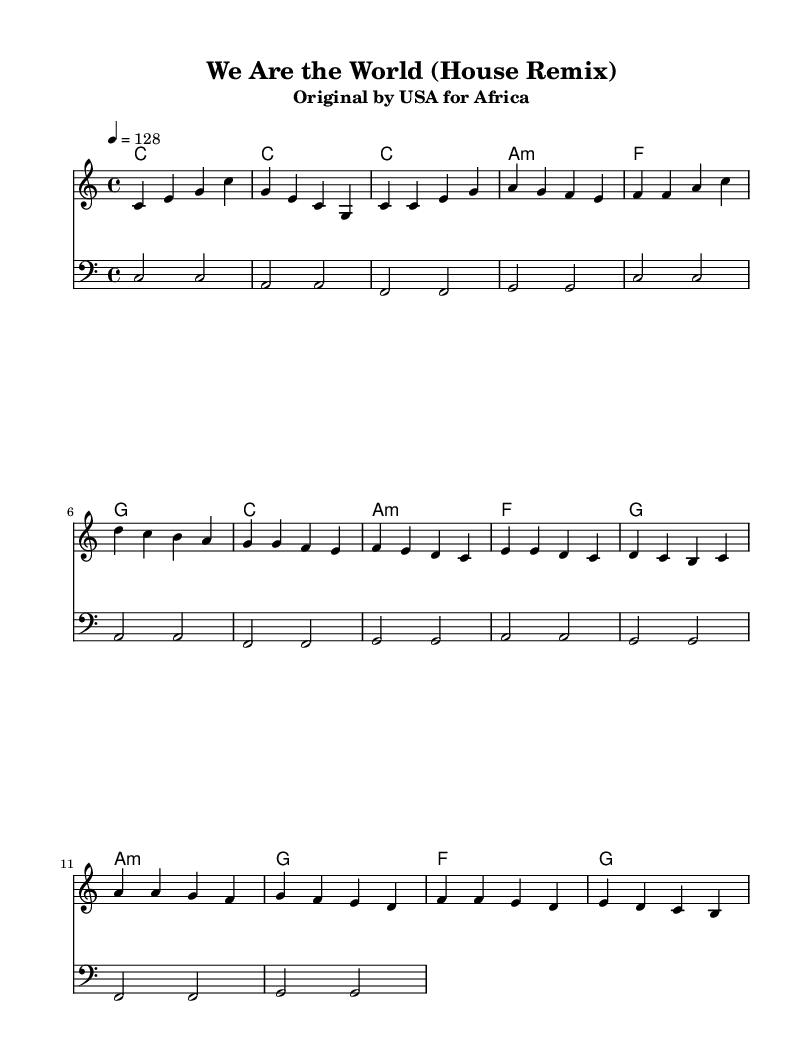What is the key signature of this music? The key signature shown in the sheet music is C major, which contains no sharps or flats, as indicated at the beginning of the staff.
Answer: C major What is the time signature of this music? The time signature is indicated at the beginning of the piece as 4/4, meaning there are four beats in each measure.
Answer: 4/4 What is the tempo marking for this music? The tempo marking specified is 4 = 128, which indicates the quarter note is played at a speed of 128 beats per minute.
Answer: 128 How many measures are there in the melody section? By counting the distinct segments in the melody part, there are a total of 16 measures in the melody.
Answer: 16 Which chord appears most frequently in the harmony section? Upon analyzing the chords listed in the harmony section, the chord C appears the most, repeated four times.
Answer: C What is the bass clef's starting note? The bassline begins with the note C, as indicated in the bass clef section of the piece.
Answer: C What type of musical form does this composition primarily follow? The structure of the piece follows a verse-chorus form, alternating between different sections repeatedly, which is typical of house remixes.
Answer: Verse-chorus 